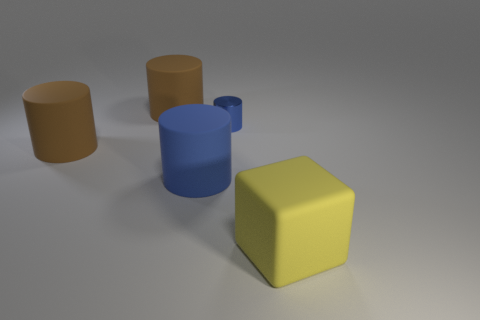What is the color of the metal thing that is the same shape as the large blue matte object?
Ensure brevity in your answer.  Blue. There is a rubber thing that is on the right side of the tiny object; does it have the same color as the metal thing?
Your answer should be compact. No. Is the blue matte object the same size as the yellow block?
Offer a very short reply. Yes. There is a yellow thing that is the same material as the big blue thing; what shape is it?
Offer a very short reply. Cube. How many other things are there of the same shape as the metallic object?
Make the answer very short. 3. There is a big brown matte object that is in front of the cylinder that is behind the blue object behind the blue rubber cylinder; what is its shape?
Keep it short and to the point. Cylinder. How many cylinders are big things or big brown things?
Keep it short and to the point. 3. There is a blue cylinder right of the large blue cylinder; is there a large brown thing in front of it?
Ensure brevity in your answer.  Yes. Is there any other thing that has the same material as the small cylinder?
Offer a terse response. No. There is a blue shiny thing; is it the same shape as the brown thing that is in front of the small shiny thing?
Provide a short and direct response. Yes. 